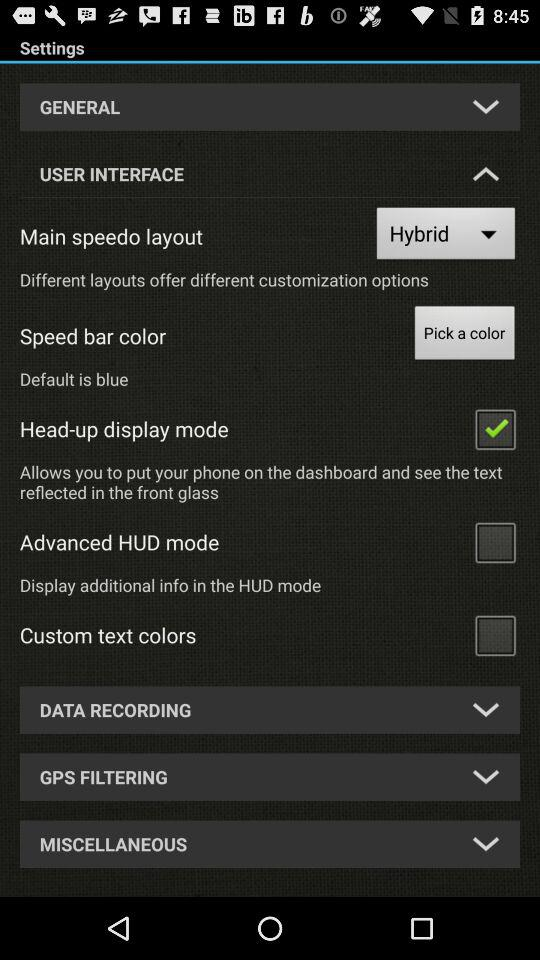What is the default color of the speed bar? The default color of the speed bar is blue. 